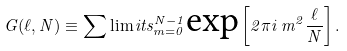<formula> <loc_0><loc_0><loc_500><loc_500>G ( \ell , N ) \equiv \sum \lim i t s _ { m = 0 } ^ { N - 1 } \text {exp} \left [ 2 \pi i \, m ^ { 2 } \frac { \ell } { N } \right ] .</formula> 